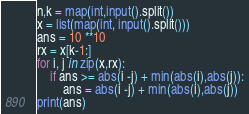Convert code to text. <code><loc_0><loc_0><loc_500><loc_500><_Python_>n,k = map(int,input().split())
x = list(map(int, input().split()))
ans = 10 **10
rx = x[k-1:]
for i, j in zip(x,rx):
    if ans >= abs(i -j) + min(abs(i),abs(j)):
        ans = abs(i -j) + min(abs(i),abs(j))
print(ans)</code> 